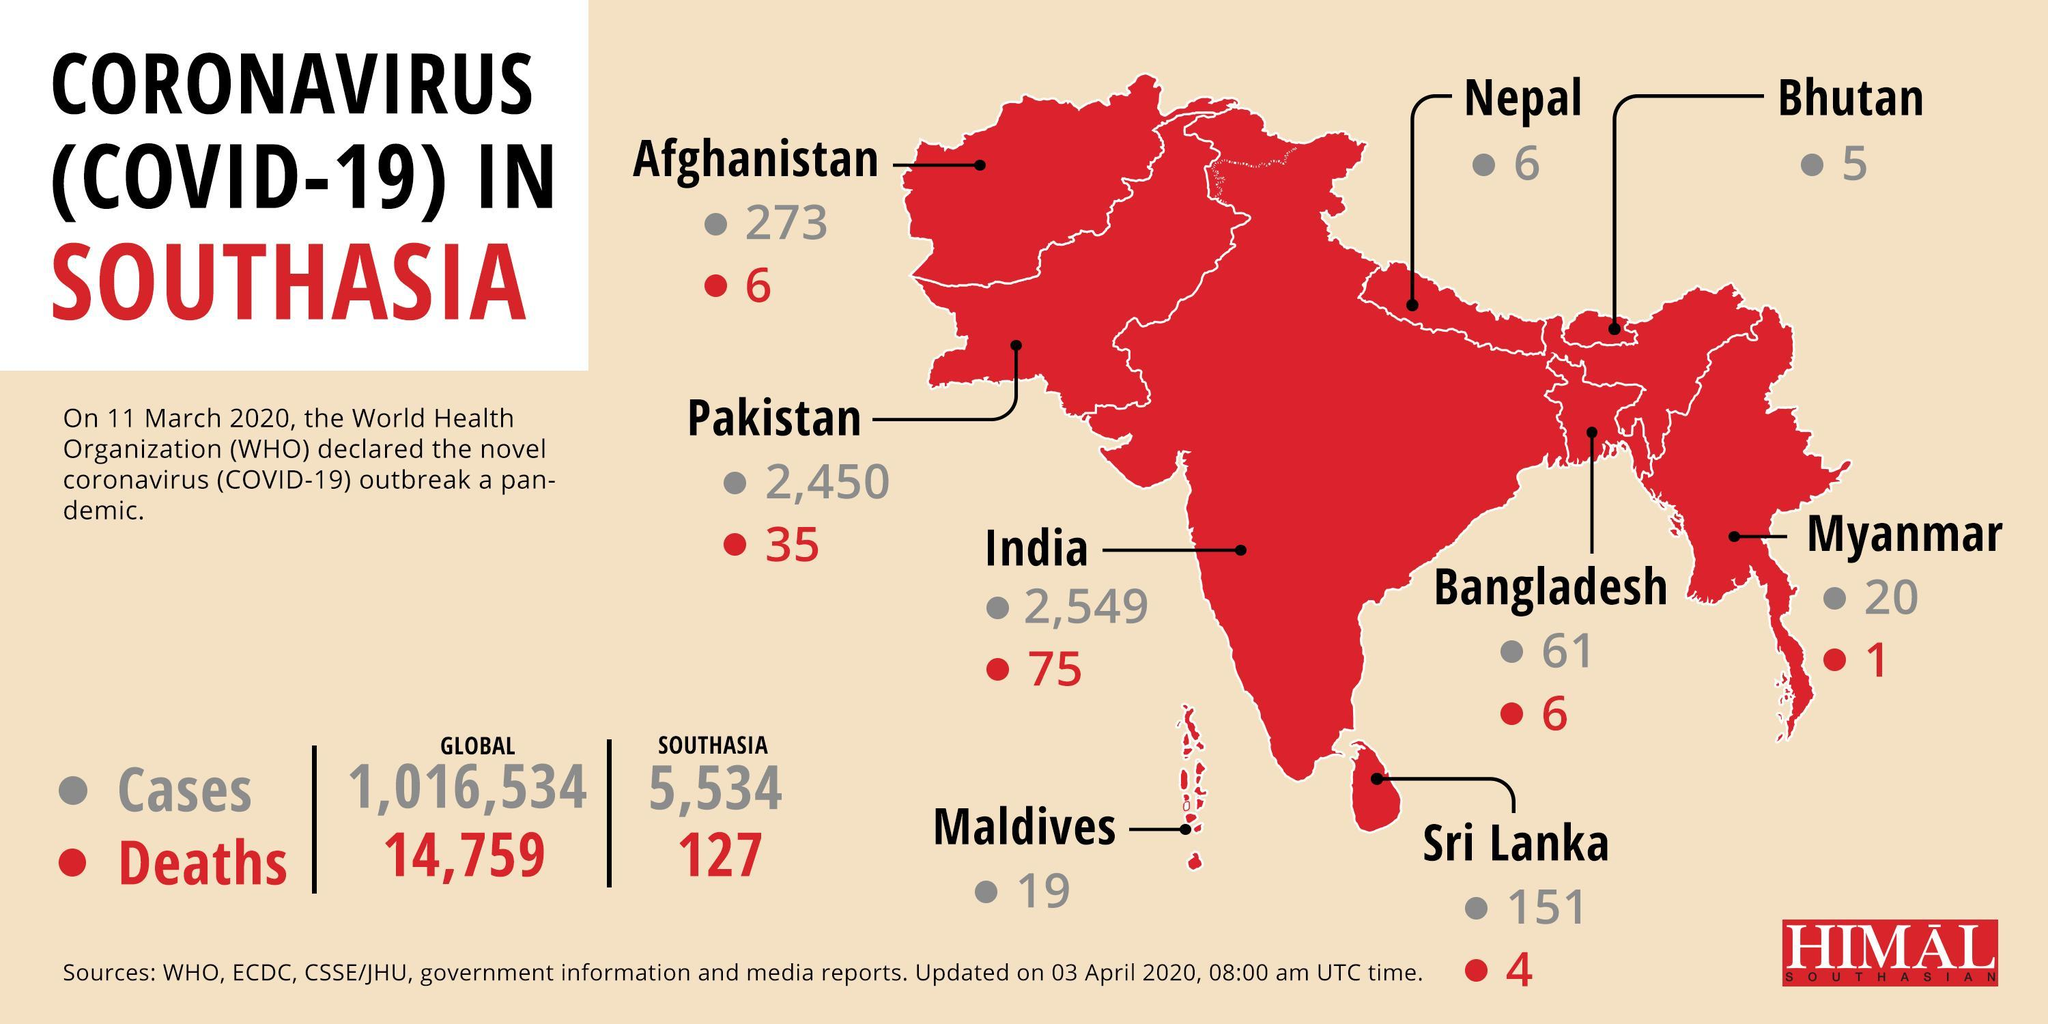How many Covid-19 deaths were reported in Bangladesh as of April 3, 2020?
Answer the question with a short phrase. 6 Which South Asian country has reported the highest number of COVID-19 cases as of April 3, 2020? India What is the number of COVID-19 cases reported in Afghanistan as of April 3, 2020? 273 Which South Asian country has reported the highest number of Covid-19 deaths as of April 3, 2020? India What is the number of COVID-19 cases reported in Myanmar as of April 3, 2020? 20 How many Covid-19 deaths were reported in Srilanka as of April 3, 2020? 4 Which South Asian country other than Nepal & Bhutan has not reported any COVID-19 deaths as of April 3, 2020? Maldives Which South Asian country has reported the least number of COVID-19 cases as of April 3, 2020? Bhutan Which South Asian country has reported the second highest number of COVID-19 cases as of April 3, 2020? Pakistan 